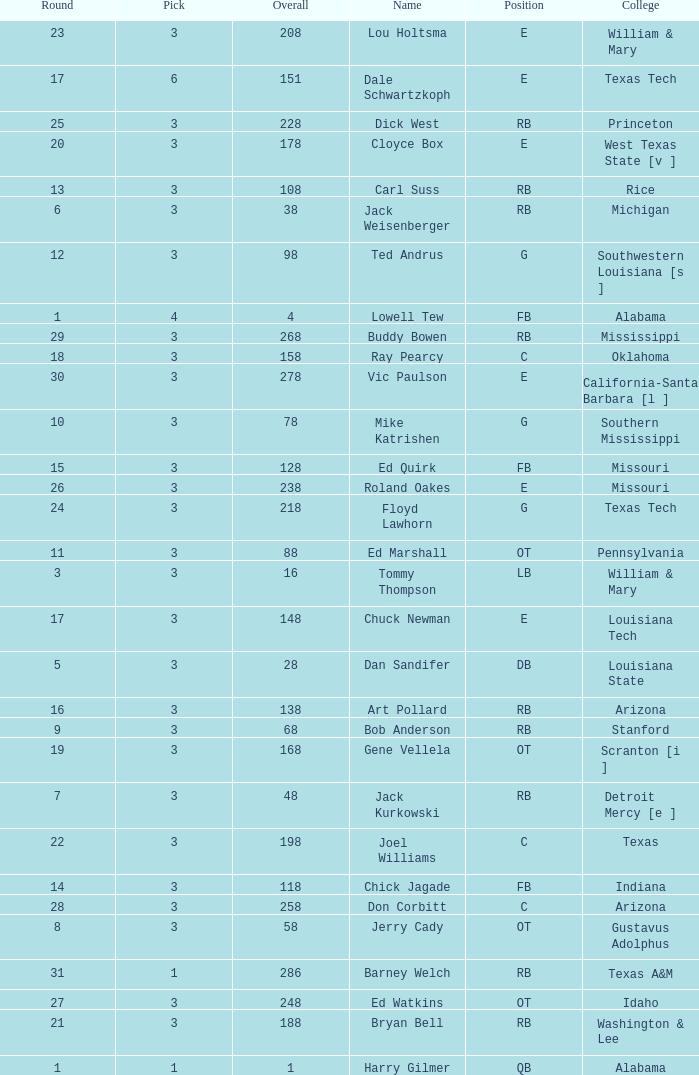How much Overall has a Name of bob anderson? 1.0. 